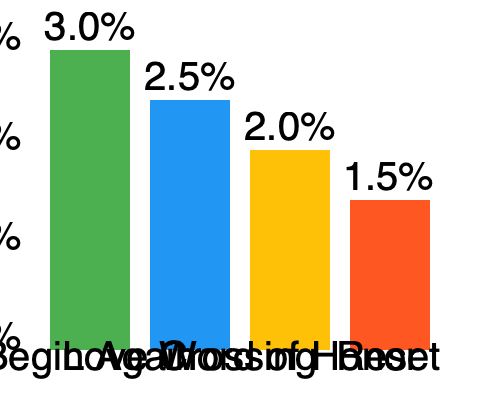Based on the bar chart showing viewership ratings for Gong Jun's dramas, calculate the percentage difference in ratings between his highest-rated drama and the average rating of his other three dramas. Express your answer as a percentage rounded to one decimal place. To solve this problem, we'll follow these steps:

1. Identify the highest-rated drama:
   Begin Again has the highest rating at 3.0%

2. Calculate the average rating of the other three dramas:
   Love Crossing: 2.5%
   Word of Honor: 2.0%
   Reset: 1.5%
   
   Average = $\frac{2.5\% + 2.0\% + 1.5\%}{3} = \frac{6\%}{3} = 2\%$

3. Calculate the difference between the highest rating and the average:
   Difference = $3.0\% - 2.0\% = 1.0\%$

4. Calculate the percentage difference:
   Percentage difference = $\frac{\text{Difference}}{\text{Average}} \times 100\%$
   $= \frac{1.0\%}{2.0\%} \times 100\% = 0.5 \times 100\% = 50\%$

5. Round to one decimal place:
   50.0%

Therefore, the percentage difference in ratings between Gong Jun's highest-rated drama and the average rating of his other three dramas is 50.0%.
Answer: 50.0% 